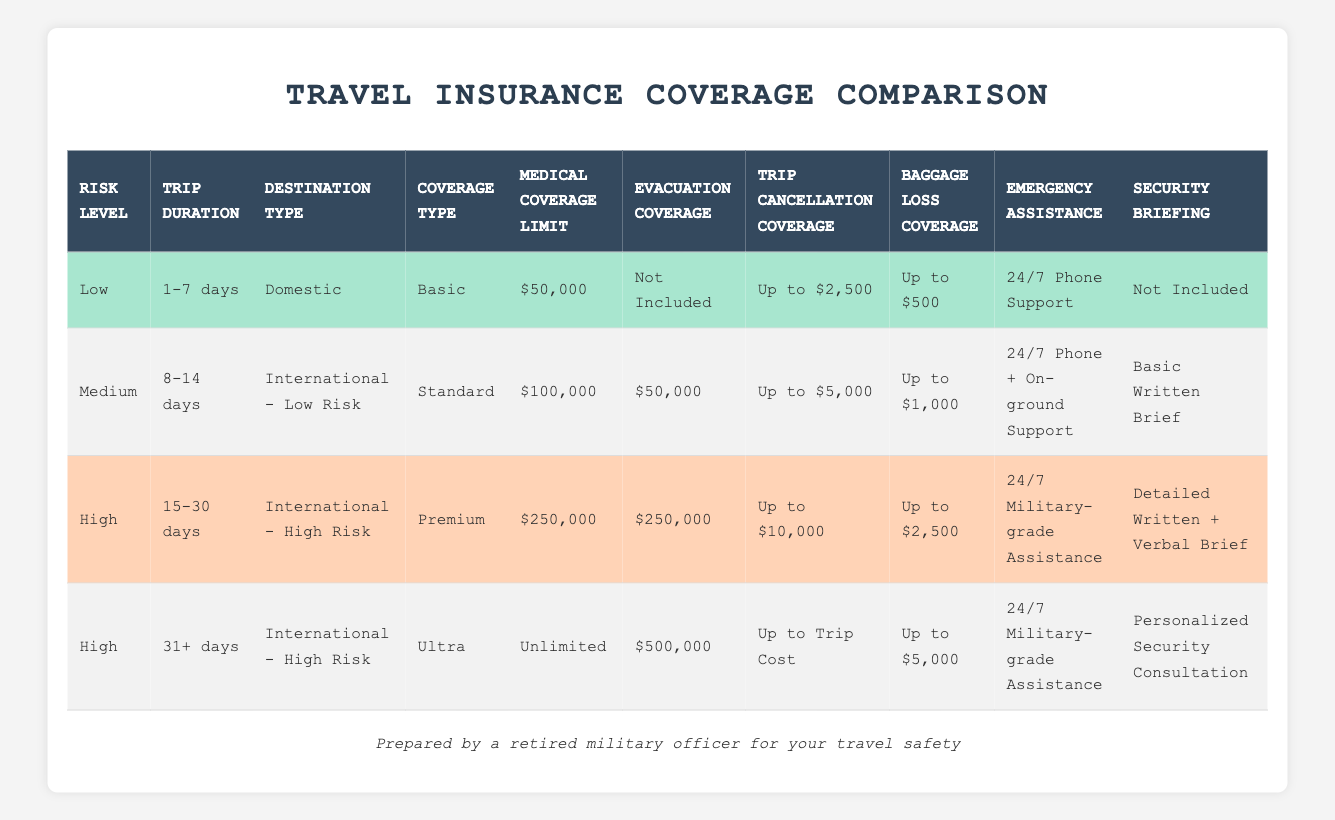What type of coverage is provided for a low-risk domestic trip lasting 1-7 days? According to the table, the coverage type for a low-risk domestic trip lasting 1-7 days is "Basic."
Answer: Basic What is the medical coverage limit for medium-risk trips that are 8-14 days long and within international low-risk destinations? The table specifies that the medical coverage limit for medium-risk trips (8-14 days, international low risk) is "$100,000."
Answer: $100,000 Is evacuation coverage included for a low-risk domestic trip? The table indicates that evacuation coverage for a low-risk domestic trip is "Not Included."
Answer: No What is the maximum trip cancellation coverage available for high-risk trips lasting 15-30 days? Based on the table, the maximum trip cancellation coverage for high-risk trips (15-30 days) is "Up to $10,000."
Answer: Up to $10,000 How does the evacuation coverage differ between high-risk trips lasting 15-30 days and those lasting 31 days or more? For high-risk trips lasting 15-30 days, the evacuation coverage is "$250,000," while for those lasting 31 or more days, it is "$500,000." This shows an increase of $250,000 for longer trips.
Answer: Increased by $250,000 What type of emergency assistance is available for high-risk trips of 31 days or more? The table indicates that high-risk trips lasting 31 days or more have "24/7 Military-grade Assistance" for emergency situations.
Answer: 24/7 Military-grade Assistance For medium-risk trips, what is the coverage type, and how does it compare to the coverage type for high-risk trips lasting 15-30 days? The coverage type for medium-risk trips (8-14 days, international low risk) is "Standard," while for high-risk trips (15-30 days), it is "Premium." "Premium" offers more comprehensive benefits than "Standard."
Answer: Standard vs. Premium Which risk level provides a personalized security consultation and what trip duration is required? The personalized security consultation is provided for high-risk trips lasting 31 days or more, as noted in the table.
Answer: High-risk, 31+ days 